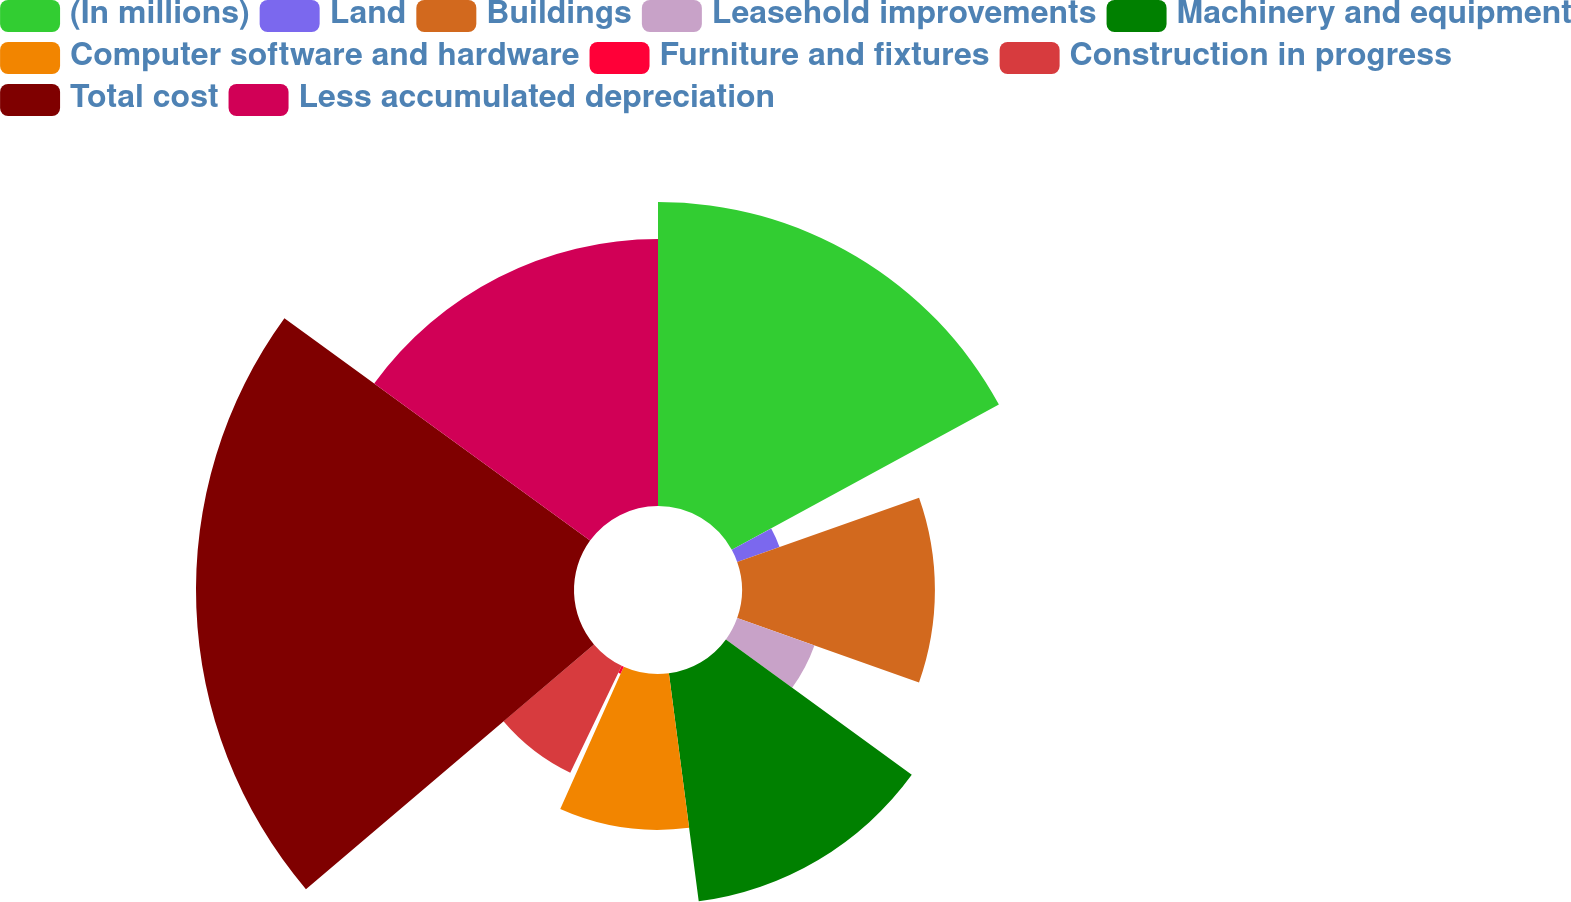Convert chart. <chart><loc_0><loc_0><loc_500><loc_500><pie_chart><fcel>(In millions)<fcel>Land<fcel>Buildings<fcel>Leasehold improvements<fcel>Machinery and equipment<fcel>Computer software and hardware<fcel>Furniture and fixtures<fcel>Construction in progress<fcel>Total cost<fcel>Less accumulated depreciation<nl><fcel>17.07%<fcel>2.52%<fcel>10.83%<fcel>4.6%<fcel>12.91%<fcel>8.75%<fcel>0.44%<fcel>6.67%<fcel>21.22%<fcel>14.99%<nl></chart> 